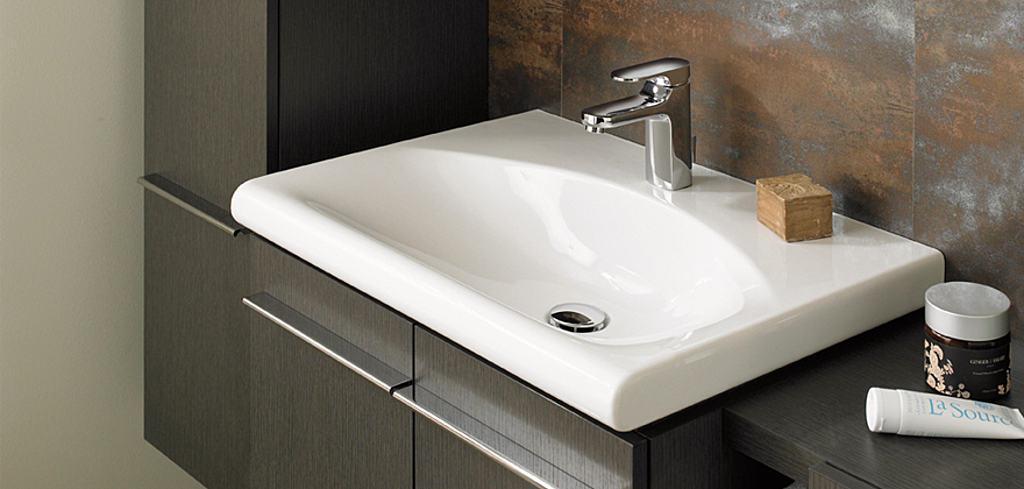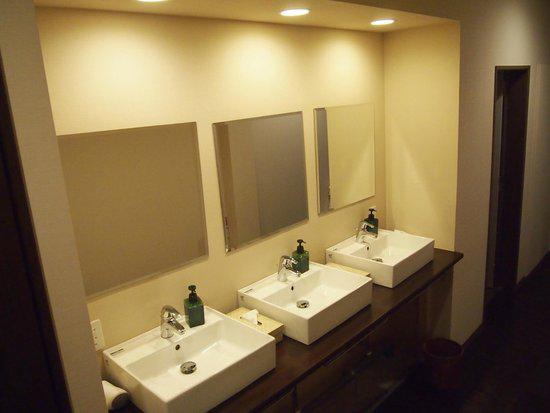The first image is the image on the left, the second image is the image on the right. Considering the images on both sides, is "There are two sinks in the image on the left." valid? Answer yes or no. No. The first image is the image on the left, the second image is the image on the right. Analyze the images presented: Is the assertion "One image shows a round mirror above a vessel sink on a vanity counter." valid? Answer yes or no. No. 